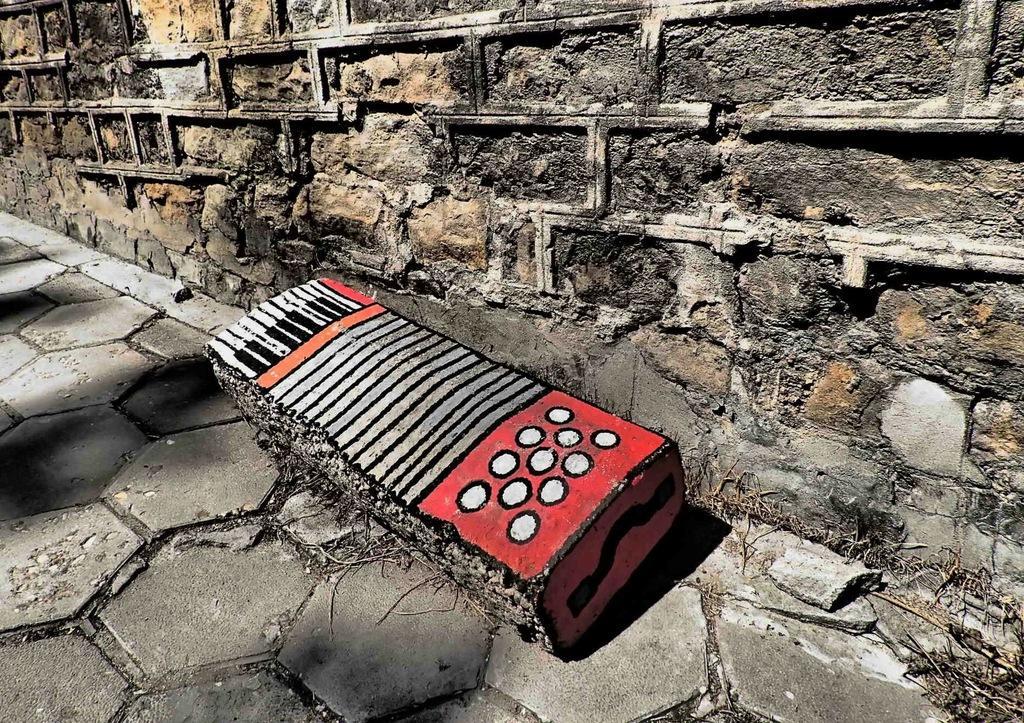How would you summarize this image in a sentence or two? In this image we can see a painting on the rock. In the background there is a wall. 